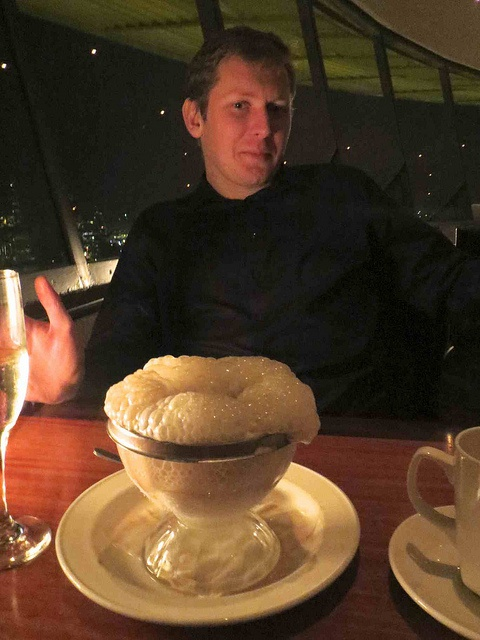Describe the objects in this image and their specific colors. I can see people in black, brown, and maroon tones, dining table in black, maroon, red, and brown tones, bowl in black, gray, maroon, and tan tones, cup in black, maroon, and gray tones, and wine glass in black, ivory, tan, and brown tones in this image. 